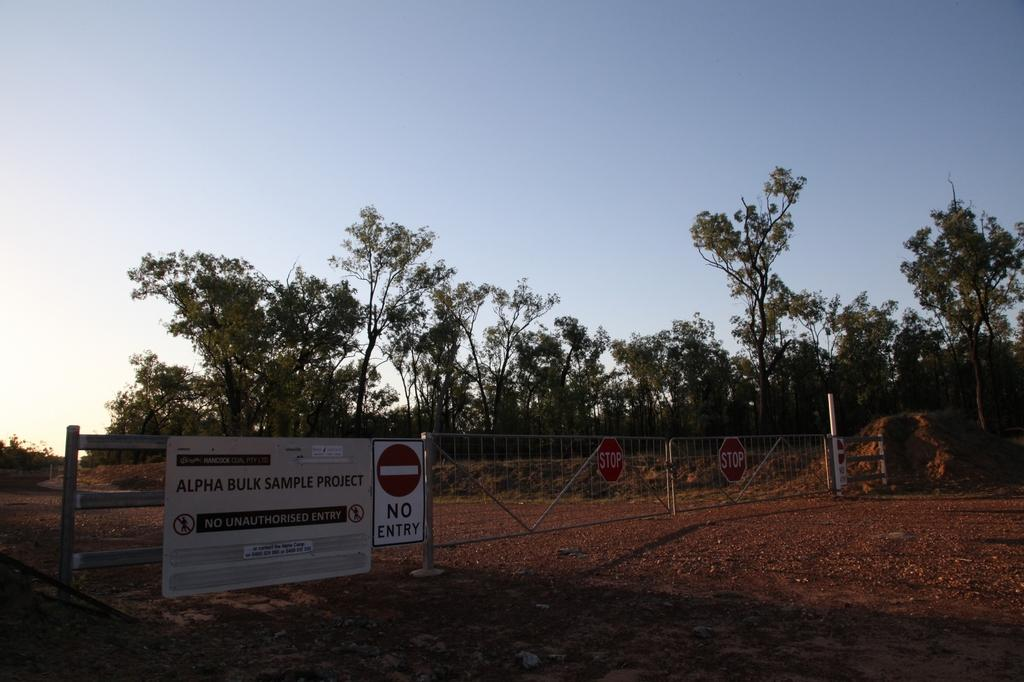What type of vegetation can be seen in the image? There are trees in the image. What object can be found in the image besides the trees? There is a board in the image. Are there any signs or notices visible in the image? Yes, there are sign boards attached to the fencing in the image. What can be seen in the background of the image? The sky is visible in the image. What type of bomb is hidden in the trees in the image? There is no bomb present in the image; it only features trees, a board, sign boards, and the sky. Can you see any pets playing in the image? There are no pets visible in the image. 